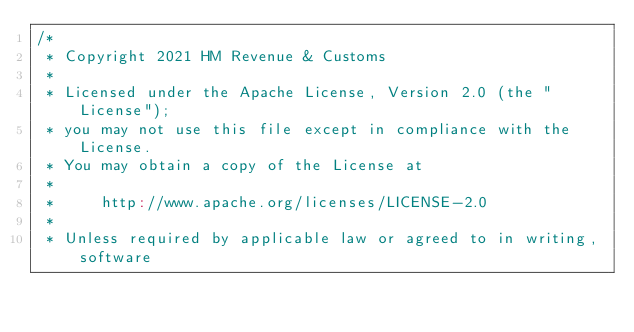<code> <loc_0><loc_0><loc_500><loc_500><_Scala_>/*
 * Copyright 2021 HM Revenue & Customs
 *
 * Licensed under the Apache License, Version 2.0 (the "License");
 * you may not use this file except in compliance with the License.
 * You may obtain a copy of the License at
 *
 *     http://www.apache.org/licenses/LICENSE-2.0
 *
 * Unless required by applicable law or agreed to in writing, software</code> 